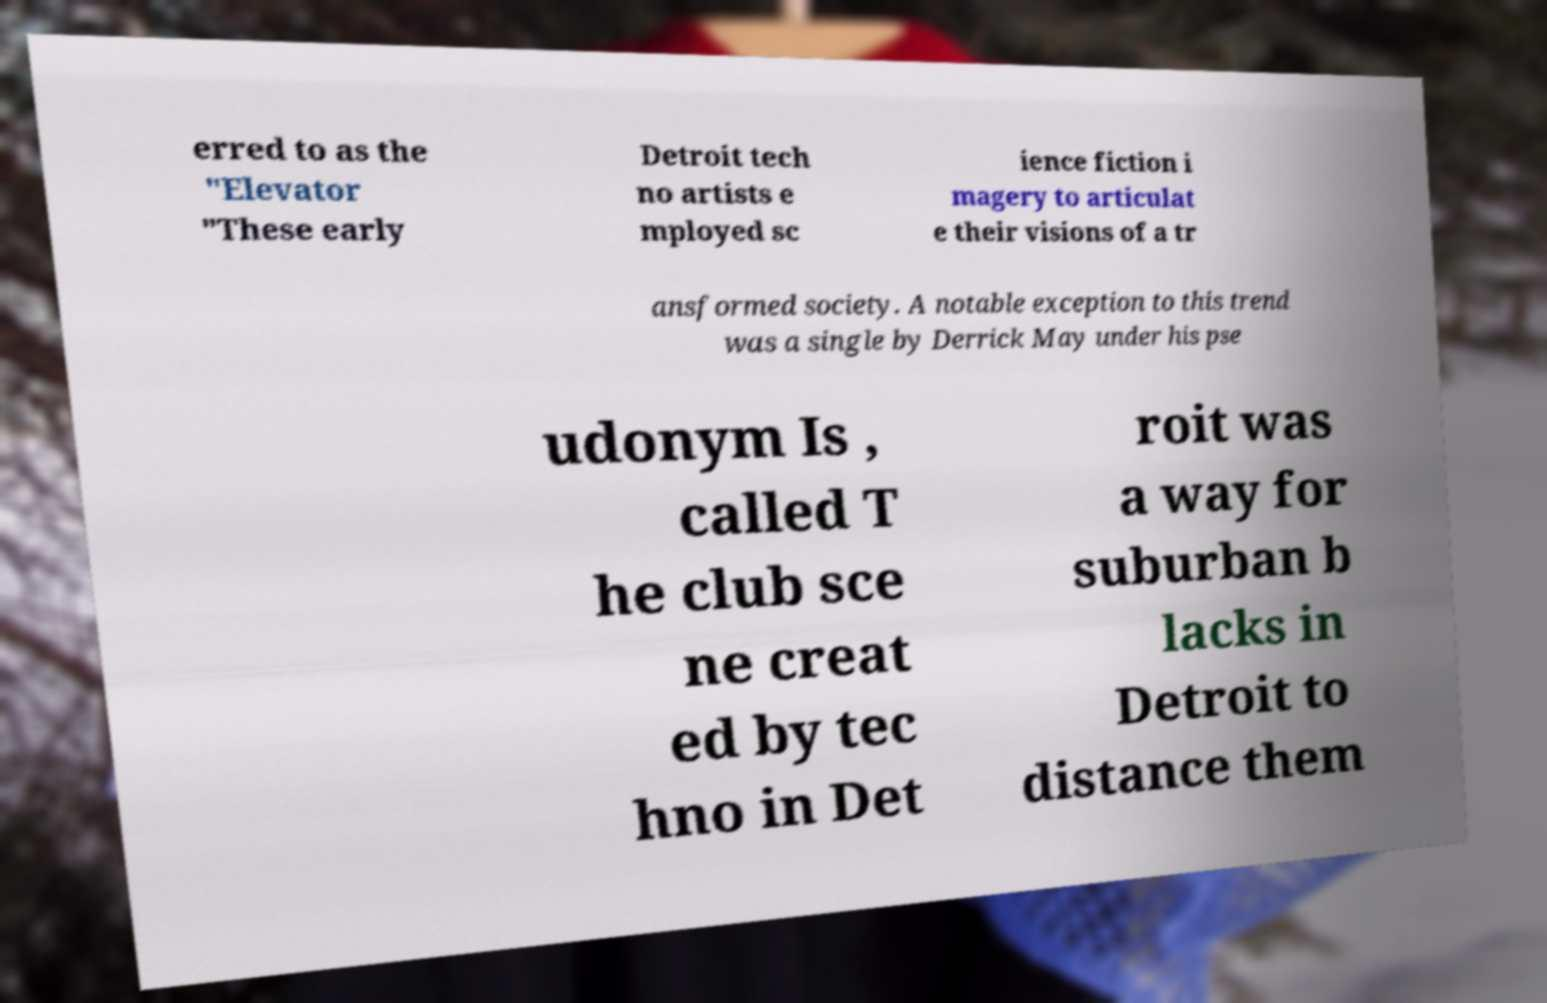Could you assist in decoding the text presented in this image and type it out clearly? erred to as the "Elevator "These early Detroit tech no artists e mployed sc ience fiction i magery to articulat e their visions of a tr ansformed society. A notable exception to this trend was a single by Derrick May under his pse udonym Is , called T he club sce ne creat ed by tec hno in Det roit was a way for suburban b lacks in Detroit to distance them 